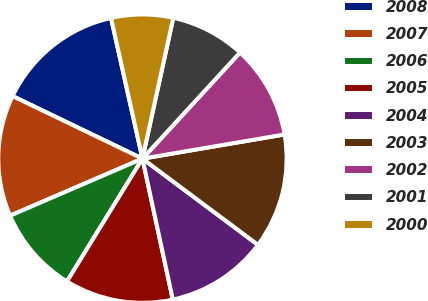Convert chart to OTSL. <chart><loc_0><loc_0><loc_500><loc_500><pie_chart><fcel>2008<fcel>2007<fcel>2006<fcel>2005<fcel>2004<fcel>2003<fcel>2002<fcel>2001<fcel>2000<nl><fcel>14.36%<fcel>13.62%<fcel>9.75%<fcel>12.15%<fcel>11.42%<fcel>12.89%<fcel>10.49%<fcel>8.4%<fcel>6.93%<nl></chart> 